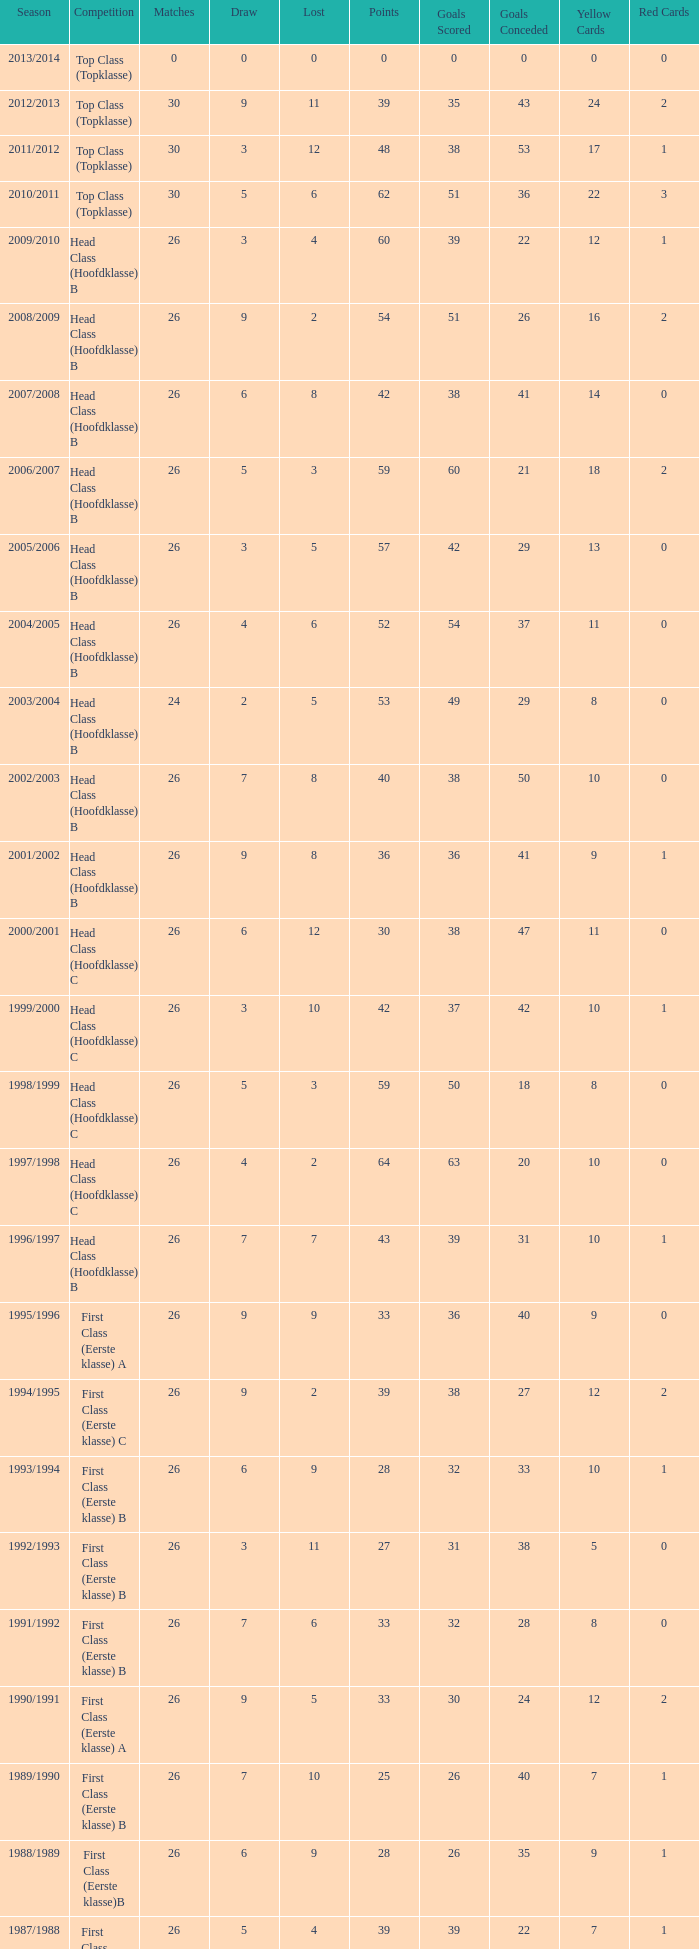What is the total number of matches with a loss less than 5 in the 2008/2009 season and has a draw larger than 9? 0.0. 